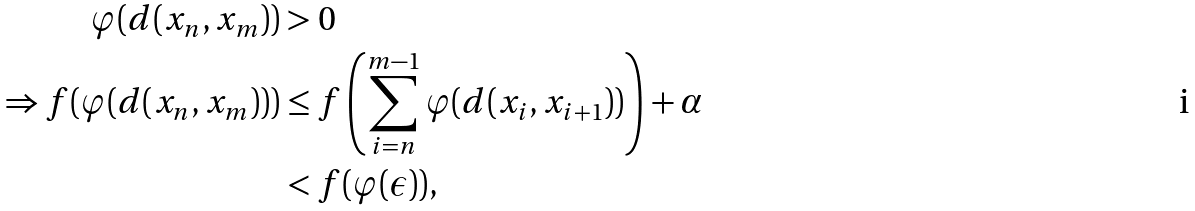Convert formula to latex. <formula><loc_0><loc_0><loc_500><loc_500>\varphi ( d ( x _ { n } , x _ { m } ) ) & > 0 \\ \Rightarrow f ( \varphi ( d ( x _ { n } , x _ { m } ) ) ) & \leq f \left ( \sum _ { i = n } ^ { m - 1 } \varphi ( d ( x _ { i } , x _ { i + 1 } ) ) \right ) + \alpha \\ & < f ( \varphi ( \epsilon ) ) ,</formula> 